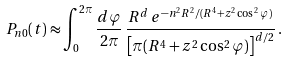<formula> <loc_0><loc_0><loc_500><loc_500>P _ { n 0 } ( t ) \approx \int _ { 0 } ^ { 2 \pi } \frac { d \varphi } { 2 \pi } \, \frac { R ^ { d } \, e ^ { - n ^ { 2 } R ^ { 2 } / ( R ^ { 4 } + z ^ { 2 } \cos ^ { 2 } \varphi ) } } { \left [ \pi ( R ^ { 4 } + z ^ { 2 } \cos ^ { 2 } \varphi ) \right ] ^ { d / 2 } } \, .</formula> 